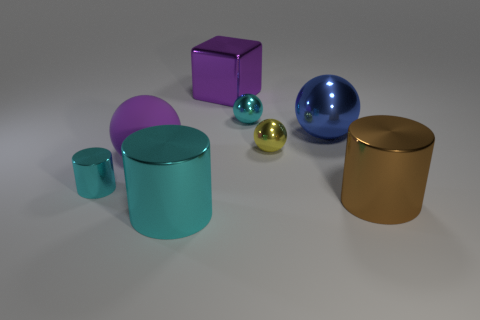There is a brown object that is the same size as the purple metallic object; what is it made of? The brown object, appearing to be the same size as the purple one, is also made of metal and has a glossy finish that suggests a possibly polished or brushed surface. 